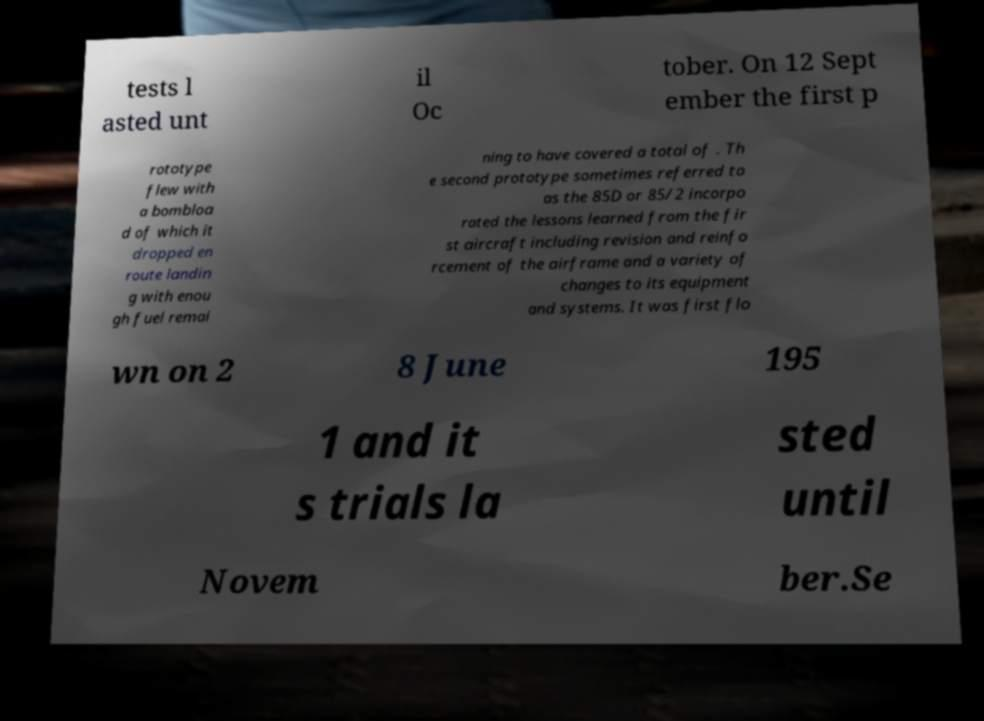Please read and relay the text visible in this image. What does it say? tests l asted unt il Oc tober. On 12 Sept ember the first p rototype flew with a bombloa d of which it dropped en route landin g with enou gh fuel remai ning to have covered a total of . Th e second prototype sometimes referred to as the 85D or 85/2 incorpo rated the lessons learned from the fir st aircraft including revision and reinfo rcement of the airframe and a variety of changes to its equipment and systems. It was first flo wn on 2 8 June 195 1 and it s trials la sted until Novem ber.Se 